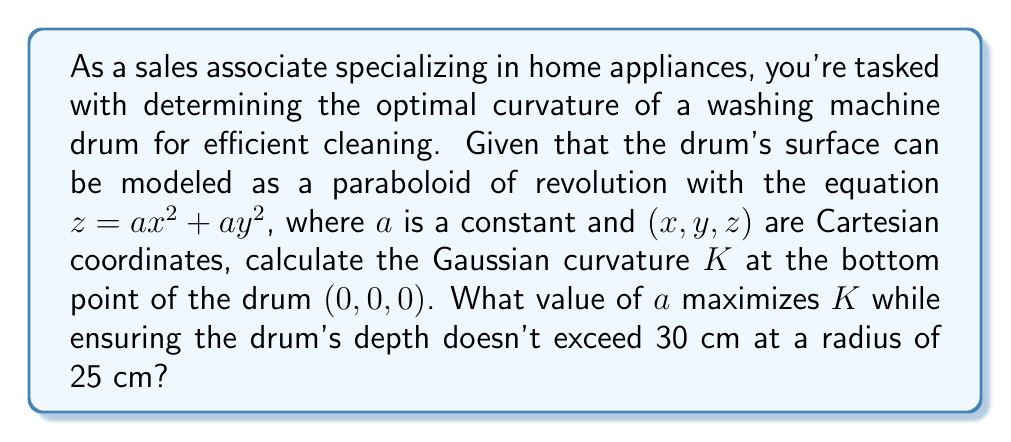Show me your answer to this math problem. Let's approach this step-by-step:

1) The Gaussian curvature $K$ of a surface $z = f(x,y)$ at a point $(x,y)$ is given by:

   $$K = \frac{f_{xx}f_{yy} - f_{xy}^2}{(1 + f_x^2 + f_y^2)^2}$$

   where subscripts denote partial derivatives.

2) For our paraboloid $z = ax^2 + ay^2$:
   $f_x = 2ax$, $f_y = 2ay$, $f_{xx} = 2a$, $f_{yy} = 2a$, $f_{xy} = 0$

3) At the bottom point $(0,0,0)$:
   $f_x = f_y = 0$, $f_{xx} = f_{yy} = 2a$, $f_{xy} = 0$

4) Substituting into the curvature formula:

   $$K = \frac{(2a)(2a) - 0^2}{(1 + 0^2 + 0^2)^2} = 4a^2$$

5) To maximize $K$, we need to maximize $a$. However, we have a constraint:
   At $r = 25$ cm, the depth shouldn't exceed 30 cm.

6) In cylindrical coordinates, our paraboloid equation becomes:
   $z = ar^2$

7) Applying the constraint:
   $30 = a(25^2)$
   $30 = 625a$
   $a = \frac{30}{625} = 0.048$

8) Therefore, the maximum value of $a$ is 0.048 cm^(-1).

9) The maximum Gaussian curvature is:
   $K = 4(0.048)^2 = 0.009216$ cm^(-2)
Answer: $K = 0.009216$ cm^(-2), $a = 0.048$ cm^(-1) 